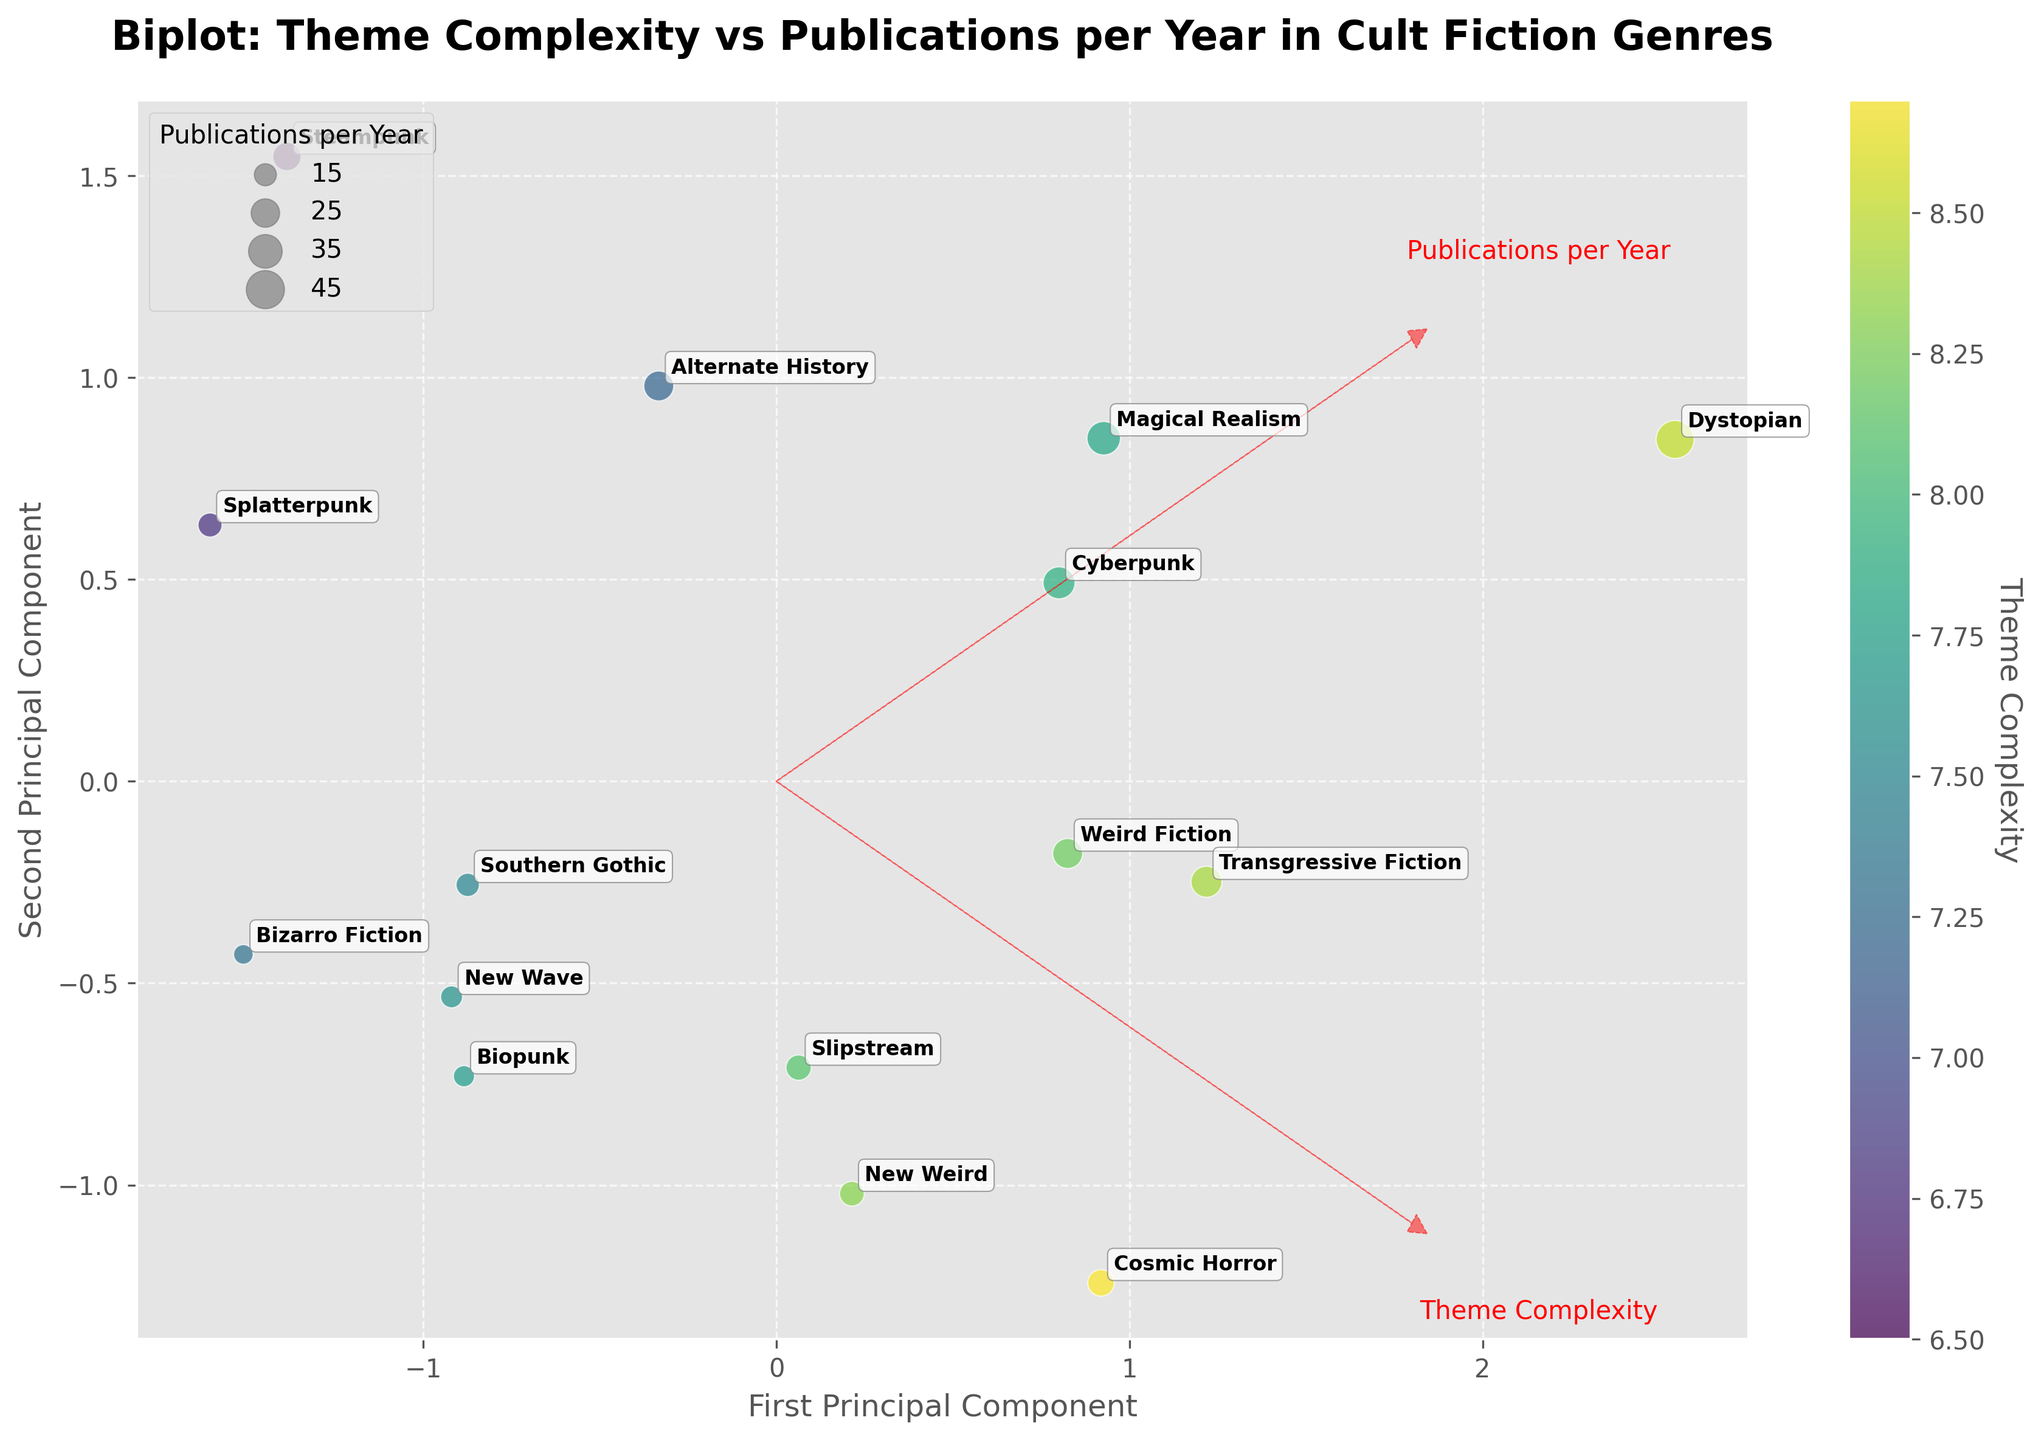What is the title of the plot? The title of the plot is located at the top of the figure. It reads 'Biplot: Theme Complexity vs Publications per Year in Cult Fiction Genres'.
Answer: Biplot: Theme Complexity vs Publications per Year in Cult Fiction Genres How many genres are represented in the plot? Each data point on the plot represents a genre. There are 15 data points corresponding to 15 genres.
Answer: 15 Which genre has the highest theme complexity? The color intensity of each data point represents theme complexity. 'Cosmic Horror' has the highest color intensity, indicating the highest theme complexity of 8.7.
Answer: Cosmic Horror Which genre has the highest number of publications per year? The size of the bubble represents the number of publications per year. 'Dystopian' has the largest bubble, indicating the highest number of publications per year, which is 45.
Answer: Dystopian What is the relationship between 'Magical Realism' and 'Cyberpunk' in terms of theme complexity and publication frequency? 'Magical Realism' and 'Cyberpunk' are close on the x-axis (First Principal Component) but differ on the y-axis (Second Principal Component). Both have moderate theme complexity (around 7.8 and 7.9 respectively). However, 'Magical Realism' has more publications (35) compared to 'Cyberpunk' (32).
Answer: 'Magical Realism' has more publications than 'Cyberpunk' Which genre appears to be an outlier in the second principal component? 'Alternate History' is further away from the y-axis compared to other genres and appears to be distant, indicating it might be an outlier in the second principal component.
Answer: Alternate History Which genre has the closest theme complexity to 'Weird Fiction'? 'Weird Fiction' has a theme complexity of 8.2. 'Slipstream', which has a theme complexity of 8.1, is the closest in theme complexity.
Answer: Slipstream Are the vectors for 'Theme Complexity' and 'Publications per Year' pointing in the same direction? The direction of the vectors indicates the correlation between the components. The vector arrows for 'Theme Complexity' and 'Publications per Year' are not pointing in the same direction, implying they are not highly correlated.
Answer: No What is the average theme complexity of the genres with more than 20 publications per year? The genres with more than 20 publications per year are 'Dystopian', 'Cyberpunk', 'Weird Fiction', 'Magical Realism', 'Steampunk', and 'Transgressive Fiction'. Their theme complexities are 8.5, 7.9, 8.2, 7.8, 6.5, and 8.4 respectively. Average = (8.5 + 7.9 + 8.2 + 7.8 + 6.5 + 8.4) / 6 = 7.88.
Answer: 7.88 